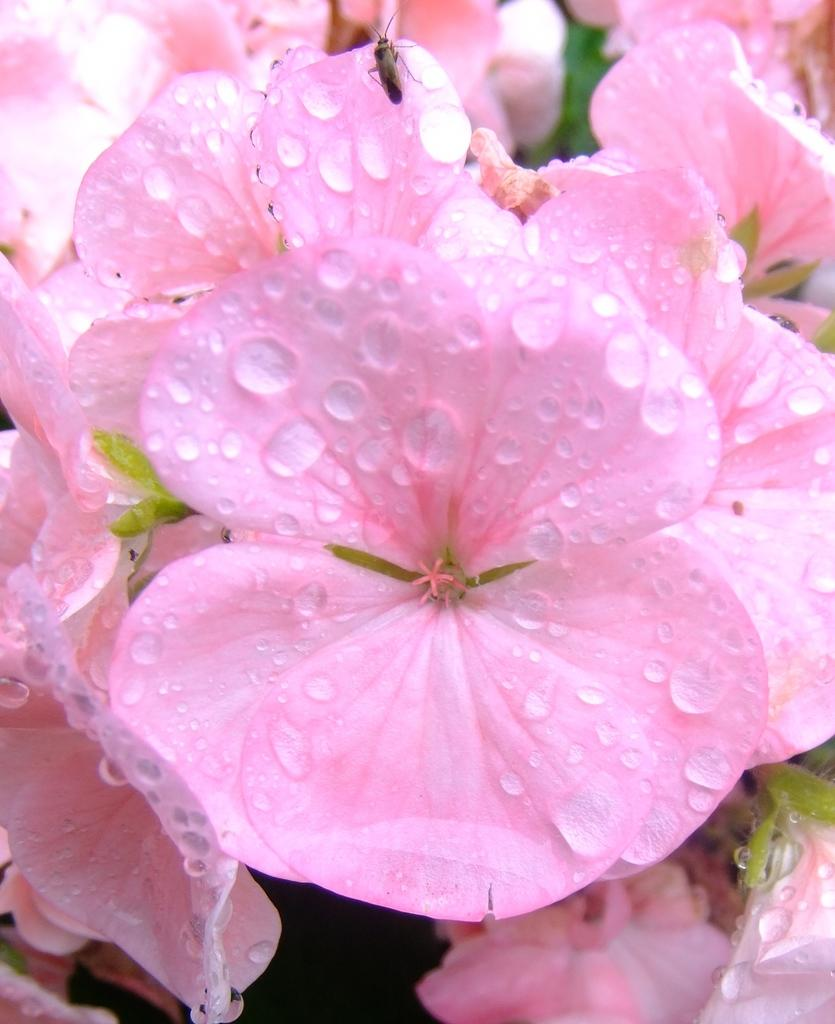What color are the flowers in the image? The flowers in the image are pink. Are there any additional features on the flowers? Yes, there are water drops on the flowers. Is there any other living organism present in the image? Yes, there is an insect on one of the flowers. What type of advertisement can be seen on the flowers in the image? There is no advertisement present on the flowers in the image. What kind of powder is visible on the insect in the image? There is no powder visible on the insect in the image. 